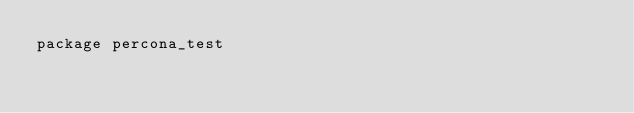Convert code to text. <code><loc_0><loc_0><loc_500><loc_500><_Go_>package percona_test
</code> 